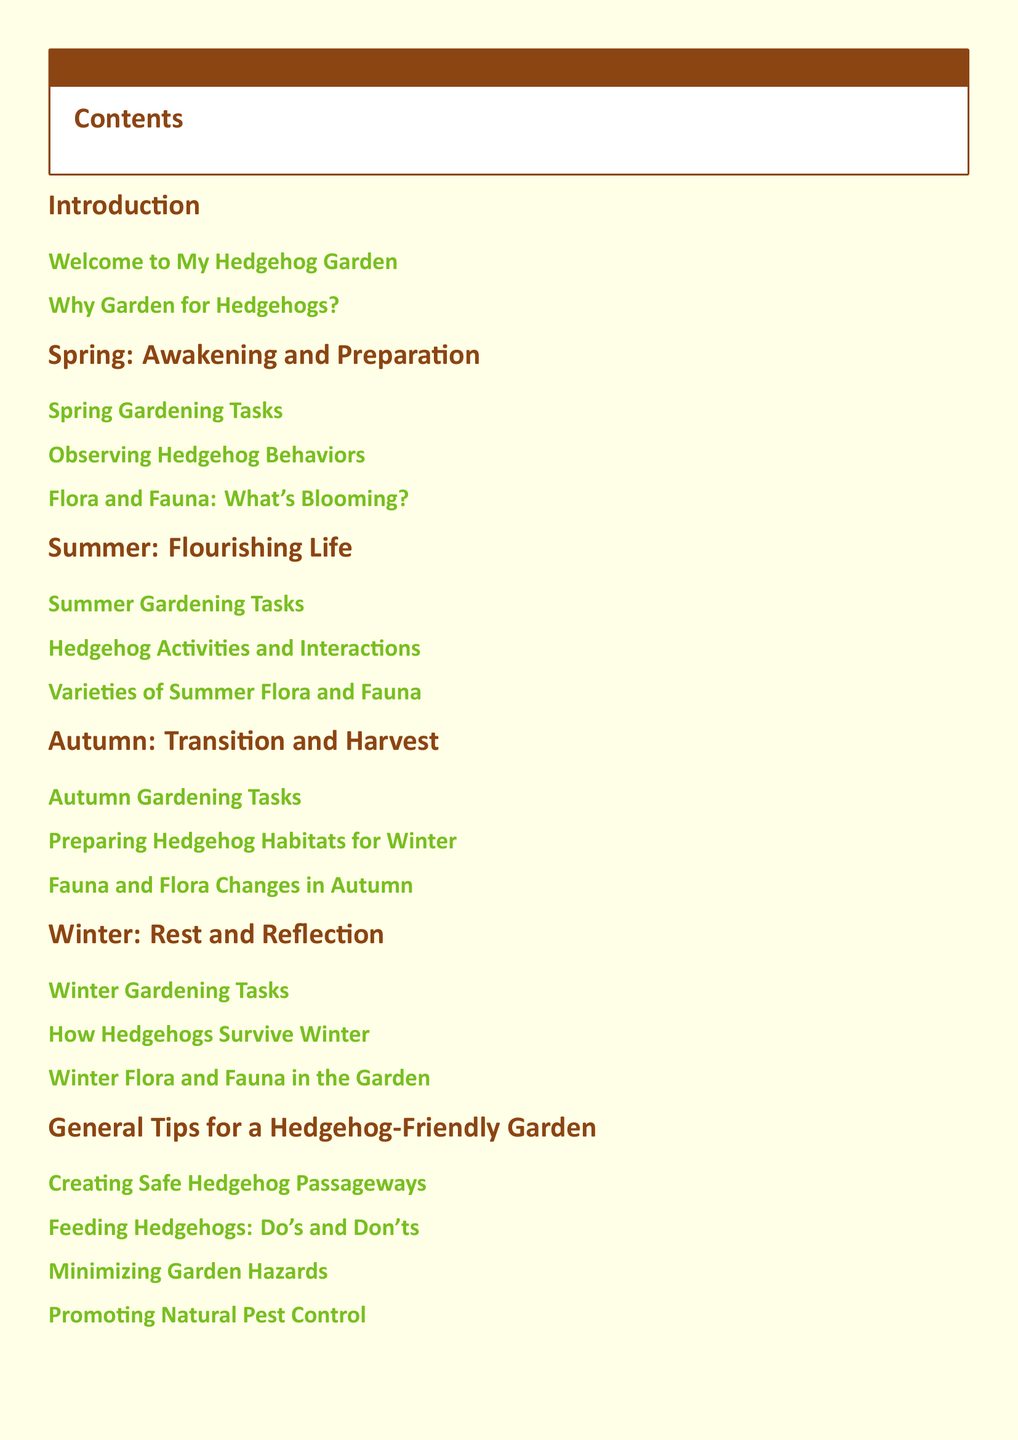What is the title of the document? The title is prominently displayed at the beginning of the document, introducing the main theme.
Answer: A Year in the Life of My Hedgehog Garden What is the first section of the document? The first section listed in the table of contents outlines the introduction to the garden.
Answer: Introduction How many seasonal sections are included in the document? The table of contents shows there are four distinct seasonal sections addressed in the document.
Answer: Four What is one of the Spring gardening tasks? The specific tasks are detailed in the corresponding section for Spring.
Answer: Spring Gardening Tasks What month does the hedgehog garden transition into winter? The seasons are indicated in the document's sections, leading to the winter phase.
Answer: Winter What tips are provided for creating a hedgehog-friendly garden? Various sub-sections include practical advice for enhancing the garden's hedgehog-friendliness.
Answer: Creating Safe Hedgehog Passageways How does the document address hedgehog survival during winter? The document contains a specific sub-section discussing these survival strategies.
Answer: How Hedgehogs Survive Winter What is encouraged in the conclusion of the document? The final section summarizes key points and promotes further engagement with the community.
Answer: Encouraging Community Involvement What does the document aim to reflect on regarding gardening? The concluding section reviews the experiences gathered throughout the year in the garden.
Answer: Reflecting on a Year of Gardening 